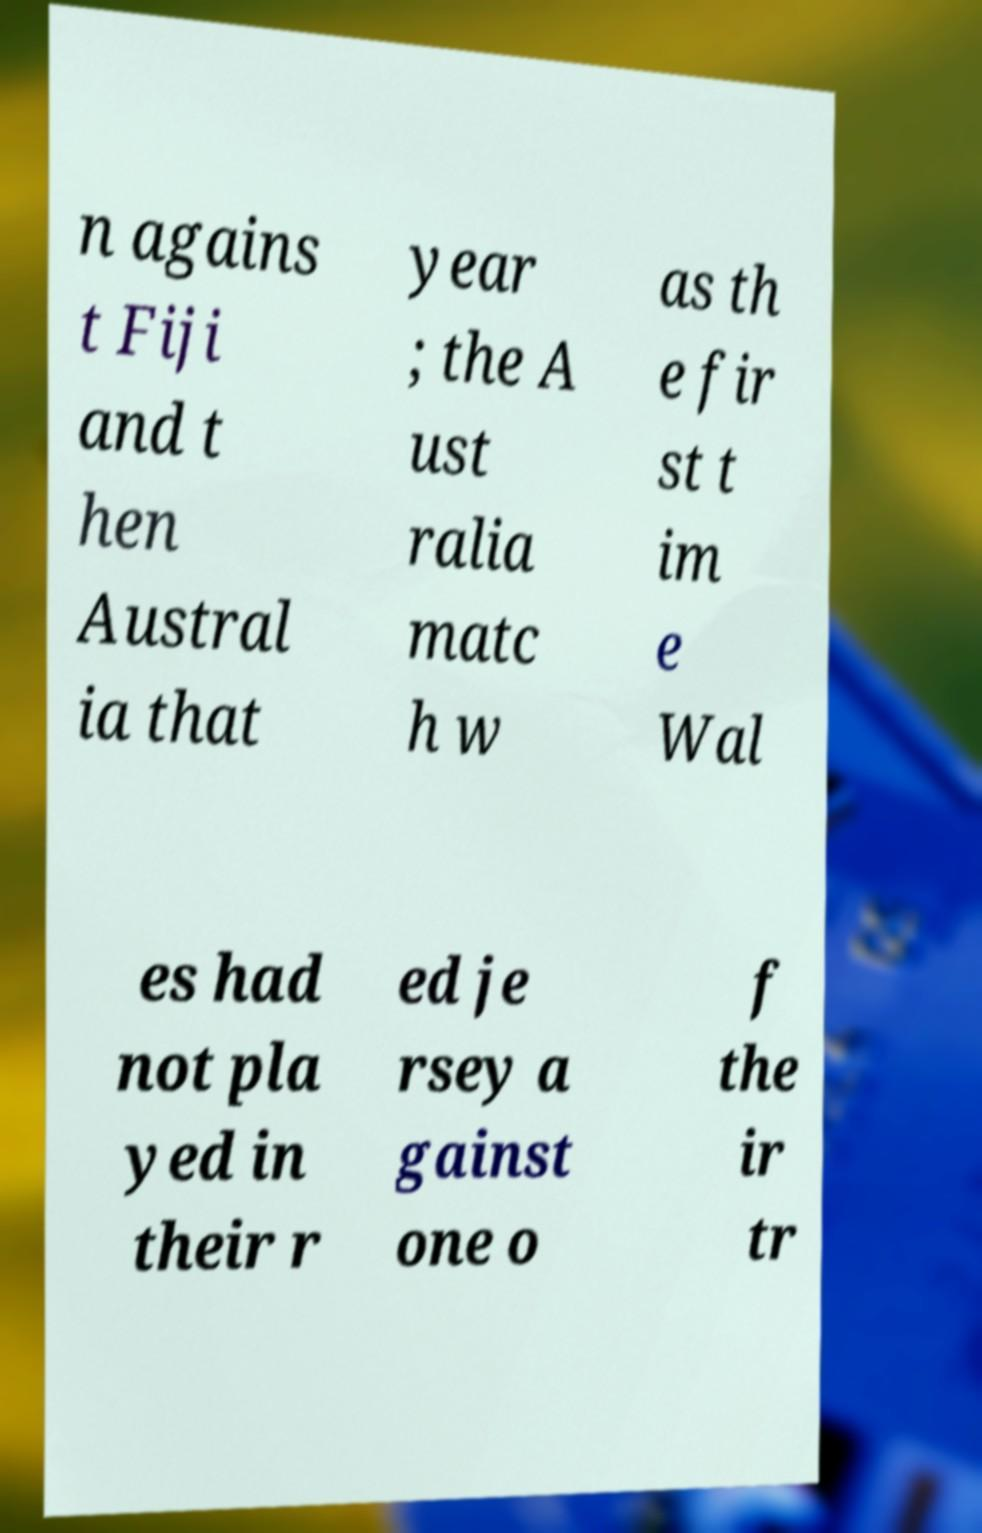Please read and relay the text visible in this image. What does it say? n agains t Fiji and t hen Austral ia that year ; the A ust ralia matc h w as th e fir st t im e Wal es had not pla yed in their r ed je rsey a gainst one o f the ir tr 